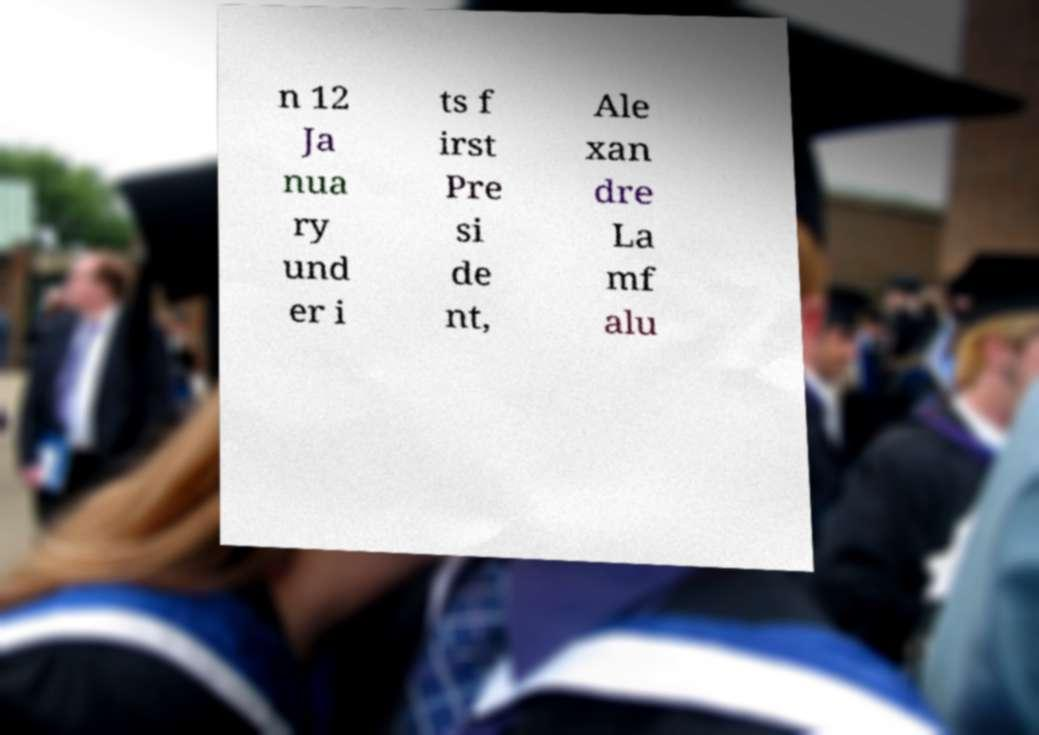Could you extract and type out the text from this image? n 12 Ja nua ry und er i ts f irst Pre si de nt, Ale xan dre La mf alu 